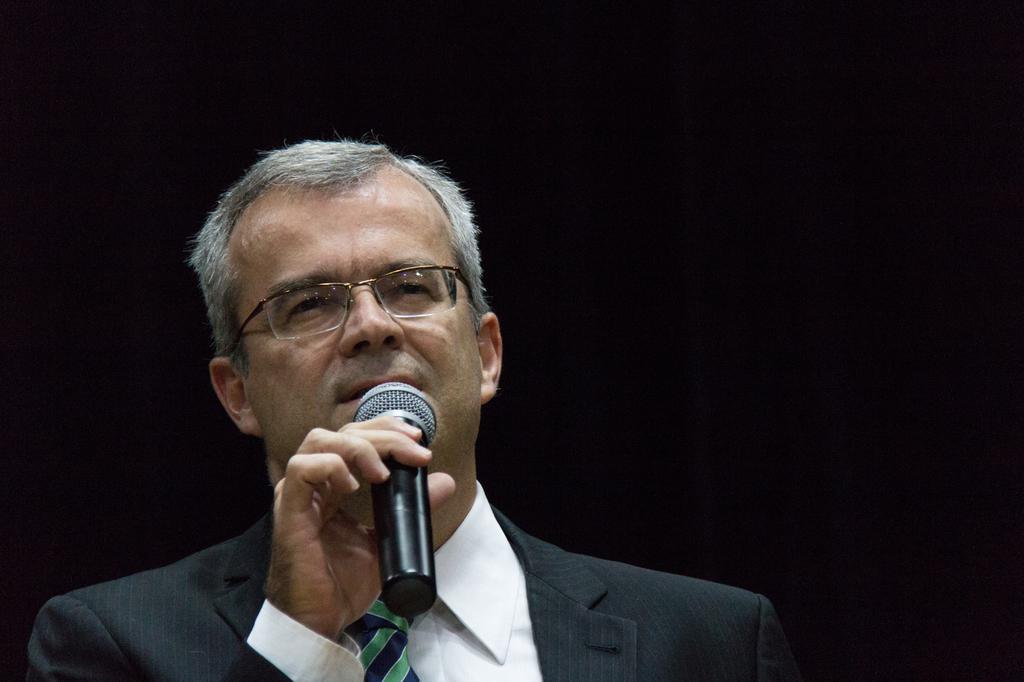Please provide a concise description of this image. This picture shows a man wearing spectacles holding a mic in his hands and talking. There is dark in the background. 